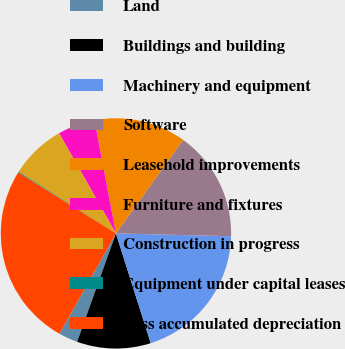<chart> <loc_0><loc_0><loc_500><loc_500><pie_chart><fcel>Land<fcel>Buildings and building<fcel>Machinery and equipment<fcel>Software<fcel>Leasehold improvements<fcel>Furniture and fixtures<fcel>Construction in progress<fcel>Equipment under capital leases<fcel>Less accumulated depreciation<nl><fcel>2.68%<fcel>10.35%<fcel>19.72%<fcel>15.47%<fcel>12.91%<fcel>5.24%<fcel>7.8%<fcel>0.12%<fcel>25.71%<nl></chart> 